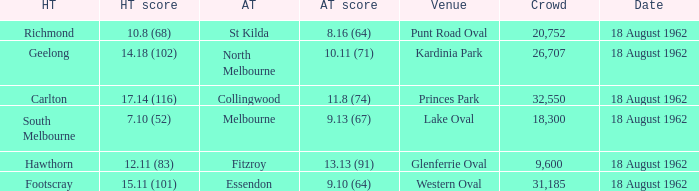At what venue where the home team scored 12.11 (83) was the crowd larger than 31,185? None. 